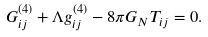<formula> <loc_0><loc_0><loc_500><loc_500>G ^ { ( 4 ) } _ { i j } + \Lambda g ^ { ( 4 ) } _ { i j } - 8 \pi G _ { N } T _ { i j } = 0 .</formula> 